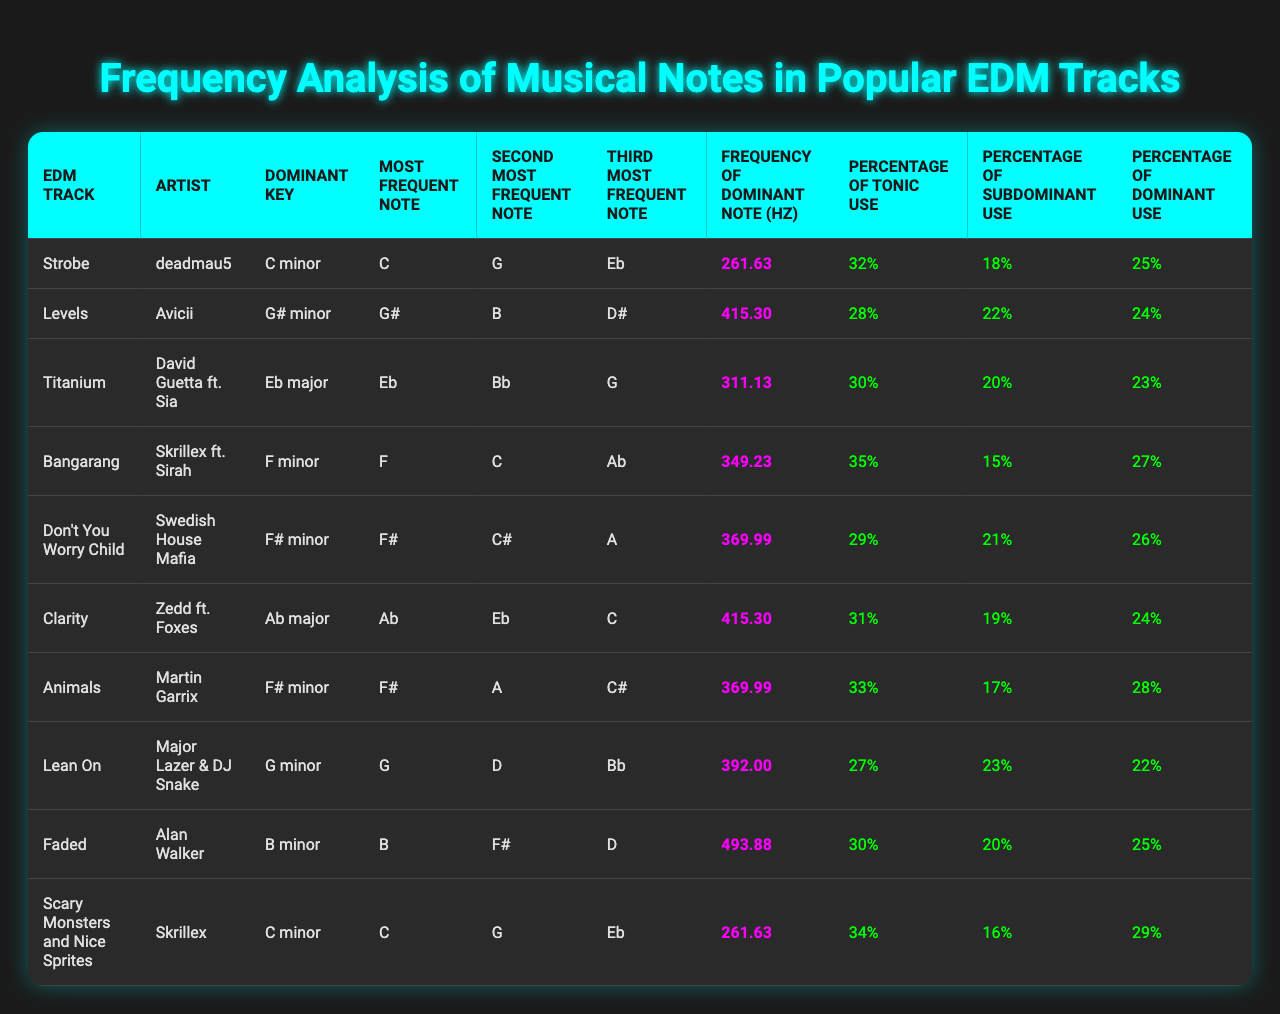What is the most frequent note in "Levels"? According to the table, "Levels" lists its most frequent note as G#.
Answer: G# Which track has the highest frequency of its dominant note in Hz? The track "Faded" has a dominant note frequency of 493.88 Hz, which is the highest among the listed tracks.
Answer: Faded What is the percentage of tonic use in "Titanium"? The table indicates that "Titanium" has a percentage of tonic use of 30%.
Answer: 30% Which track shows a higher percentage of subdominant use: "Strobe" or "Bangarang"? "Strobe" has a subdominant percentage of 18%, while "Bangarang" shows 15%. Thus, "Strobe" has a higher percentage of subdominant use.
Answer: Strobe Calculate the total percentage of tonic and subdominant use for "Don't You Worry Child". The tonic use is 29% and the subdominant use is 21%. Adding them together gives 29% + 21% = 50%.
Answer: 50% Is "Faded" in a minor key? Based on the table, "Faded" is in B minor, which confirms that it is indeed a minor key.
Answer: Yes Which track has the lowest percentage of dominant use? Upon checking the values, "Lean On" has the lowest percentage of dominant use at 22%.
Answer: Lean On What is the median frequency of the dominant notes in this table? First, list the frequencies: 261.63, 415.30, 311.13, 349.23, 369.99, 415.30, 369.99, 392.00, 493.88, 261.63. The median value must be calculated by sorting the list and finding the middle value, which is 369.99.
Answer: 369.99 How many tracks have a dominant note frequency higher than 400 Hz? By examining the table, "Levels," "Clarity," and "Faded" all have frequencies higher than 400 Hz, totaling 3 tracks.
Answer: 3 Which artist has the most frequent use of the tonic note and what is the percentage? "Bangarang" by Skrillex has the highest tonic use at 35%.
Answer: Bangarang, 35% 